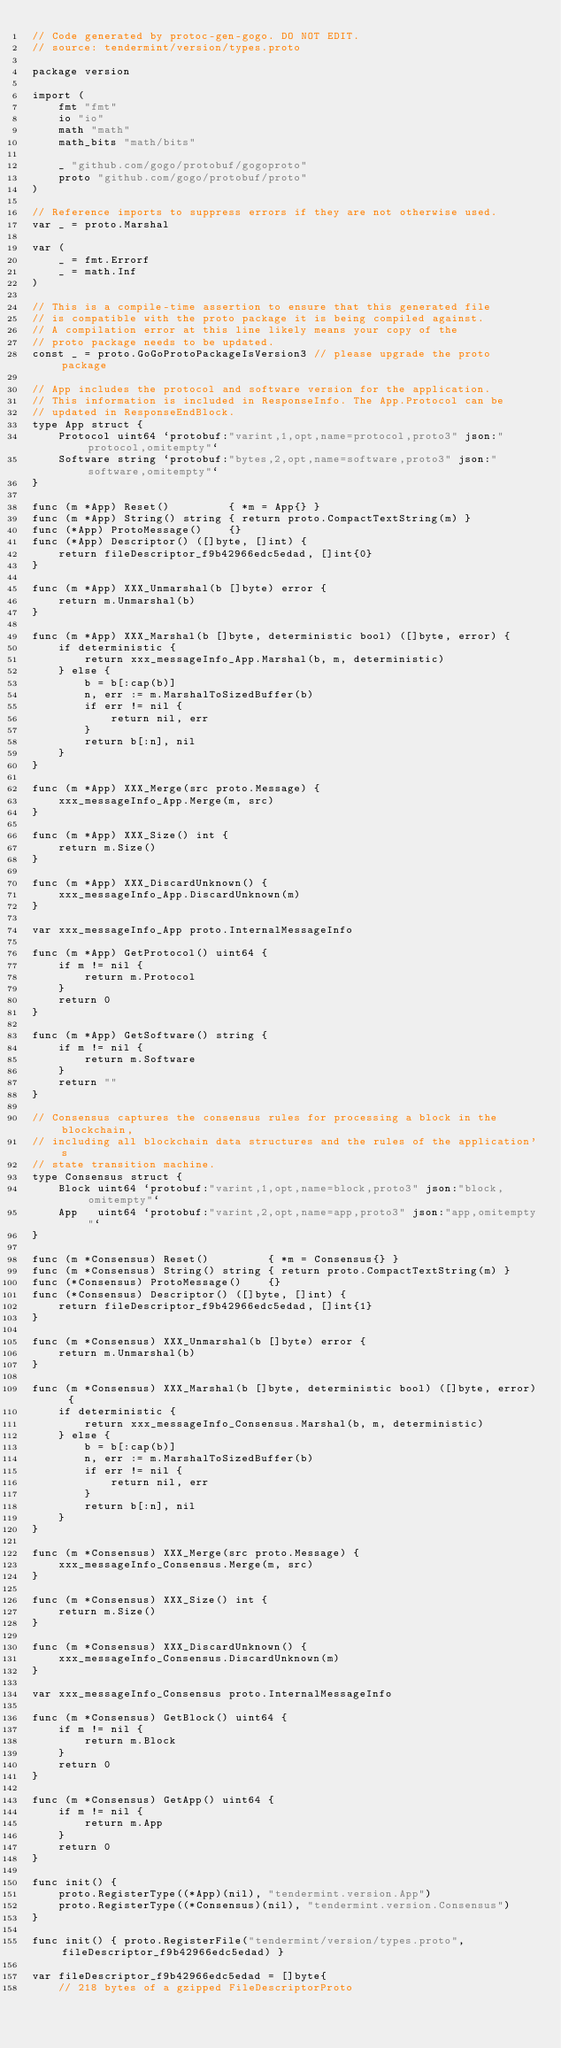<code> <loc_0><loc_0><loc_500><loc_500><_Go_>// Code generated by protoc-gen-gogo. DO NOT EDIT.
// source: tendermint/version/types.proto

package version

import (
	fmt "fmt"
	io "io"
	math "math"
	math_bits "math/bits"

	_ "github.com/gogo/protobuf/gogoproto"
	proto "github.com/gogo/protobuf/proto"
)

// Reference imports to suppress errors if they are not otherwise used.
var _ = proto.Marshal

var (
	_ = fmt.Errorf
	_ = math.Inf
)

// This is a compile-time assertion to ensure that this generated file
// is compatible with the proto package it is being compiled against.
// A compilation error at this line likely means your copy of the
// proto package needs to be updated.
const _ = proto.GoGoProtoPackageIsVersion3 // please upgrade the proto package

// App includes the protocol and software version for the application.
// This information is included in ResponseInfo. The App.Protocol can be
// updated in ResponseEndBlock.
type App struct {
	Protocol uint64 `protobuf:"varint,1,opt,name=protocol,proto3" json:"protocol,omitempty"`
	Software string `protobuf:"bytes,2,opt,name=software,proto3" json:"software,omitempty"`
}

func (m *App) Reset()         { *m = App{} }
func (m *App) String() string { return proto.CompactTextString(m) }
func (*App) ProtoMessage()    {}
func (*App) Descriptor() ([]byte, []int) {
	return fileDescriptor_f9b42966edc5edad, []int{0}
}

func (m *App) XXX_Unmarshal(b []byte) error {
	return m.Unmarshal(b)
}

func (m *App) XXX_Marshal(b []byte, deterministic bool) ([]byte, error) {
	if deterministic {
		return xxx_messageInfo_App.Marshal(b, m, deterministic)
	} else {
		b = b[:cap(b)]
		n, err := m.MarshalToSizedBuffer(b)
		if err != nil {
			return nil, err
		}
		return b[:n], nil
	}
}

func (m *App) XXX_Merge(src proto.Message) {
	xxx_messageInfo_App.Merge(m, src)
}

func (m *App) XXX_Size() int {
	return m.Size()
}

func (m *App) XXX_DiscardUnknown() {
	xxx_messageInfo_App.DiscardUnknown(m)
}

var xxx_messageInfo_App proto.InternalMessageInfo

func (m *App) GetProtocol() uint64 {
	if m != nil {
		return m.Protocol
	}
	return 0
}

func (m *App) GetSoftware() string {
	if m != nil {
		return m.Software
	}
	return ""
}

// Consensus captures the consensus rules for processing a block in the blockchain,
// including all blockchain data structures and the rules of the application's
// state transition machine.
type Consensus struct {
	Block uint64 `protobuf:"varint,1,opt,name=block,proto3" json:"block,omitempty"`
	App   uint64 `protobuf:"varint,2,opt,name=app,proto3" json:"app,omitempty"`
}

func (m *Consensus) Reset()         { *m = Consensus{} }
func (m *Consensus) String() string { return proto.CompactTextString(m) }
func (*Consensus) ProtoMessage()    {}
func (*Consensus) Descriptor() ([]byte, []int) {
	return fileDescriptor_f9b42966edc5edad, []int{1}
}

func (m *Consensus) XXX_Unmarshal(b []byte) error {
	return m.Unmarshal(b)
}

func (m *Consensus) XXX_Marshal(b []byte, deterministic bool) ([]byte, error) {
	if deterministic {
		return xxx_messageInfo_Consensus.Marshal(b, m, deterministic)
	} else {
		b = b[:cap(b)]
		n, err := m.MarshalToSizedBuffer(b)
		if err != nil {
			return nil, err
		}
		return b[:n], nil
	}
}

func (m *Consensus) XXX_Merge(src proto.Message) {
	xxx_messageInfo_Consensus.Merge(m, src)
}

func (m *Consensus) XXX_Size() int {
	return m.Size()
}

func (m *Consensus) XXX_DiscardUnknown() {
	xxx_messageInfo_Consensus.DiscardUnknown(m)
}

var xxx_messageInfo_Consensus proto.InternalMessageInfo

func (m *Consensus) GetBlock() uint64 {
	if m != nil {
		return m.Block
	}
	return 0
}

func (m *Consensus) GetApp() uint64 {
	if m != nil {
		return m.App
	}
	return 0
}

func init() {
	proto.RegisterType((*App)(nil), "tendermint.version.App")
	proto.RegisterType((*Consensus)(nil), "tendermint.version.Consensus")
}

func init() { proto.RegisterFile("tendermint/version/types.proto", fileDescriptor_f9b42966edc5edad) }

var fileDescriptor_f9b42966edc5edad = []byte{
	// 218 bytes of a gzipped FileDescriptorProto</code> 